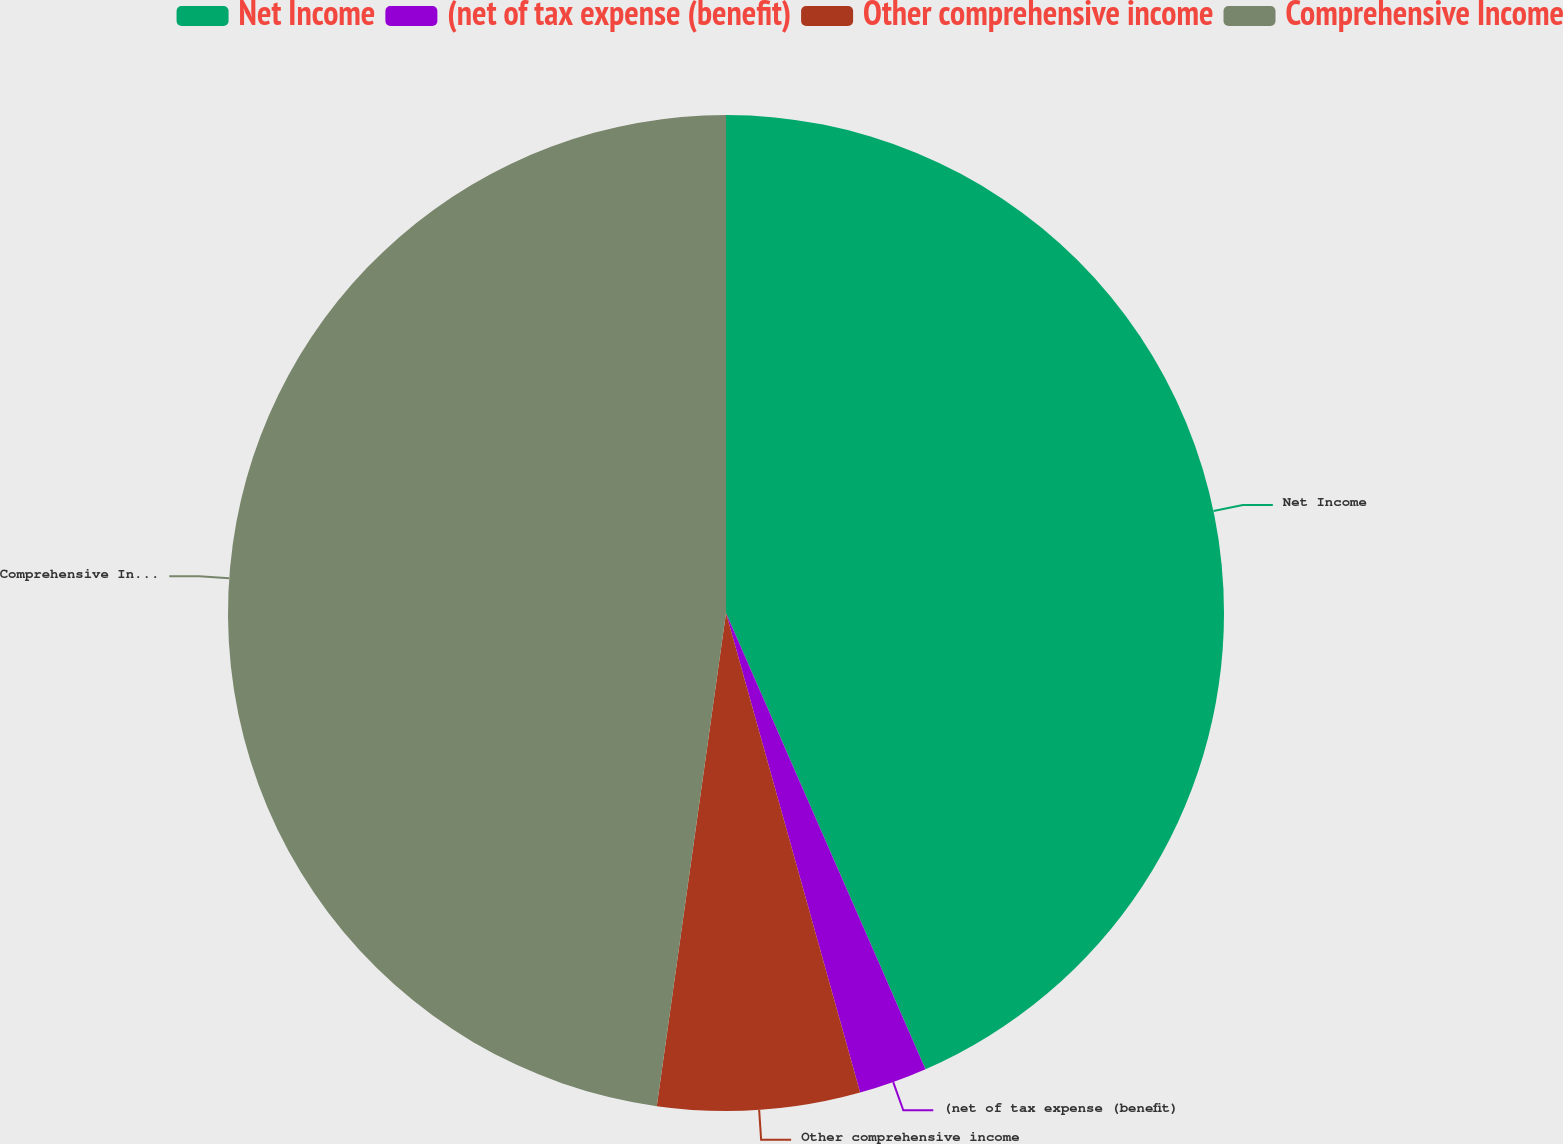<chart> <loc_0><loc_0><loc_500><loc_500><pie_chart><fcel>Net Income<fcel>(net of tax expense (benefit)<fcel>Other comprehensive income<fcel>Comprehensive Income<nl><fcel>43.44%<fcel>2.22%<fcel>6.56%<fcel>47.78%<nl></chart> 